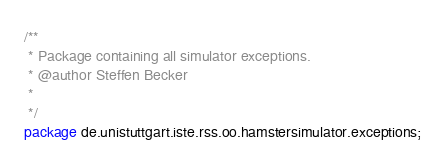<code> <loc_0><loc_0><loc_500><loc_500><_Java_>/**
 * Package containing all simulator exceptions.
 * @author Steffen Becker
 *
 */
package de.unistuttgart.iste.rss.oo.hamstersimulator.exceptions;
</code> 